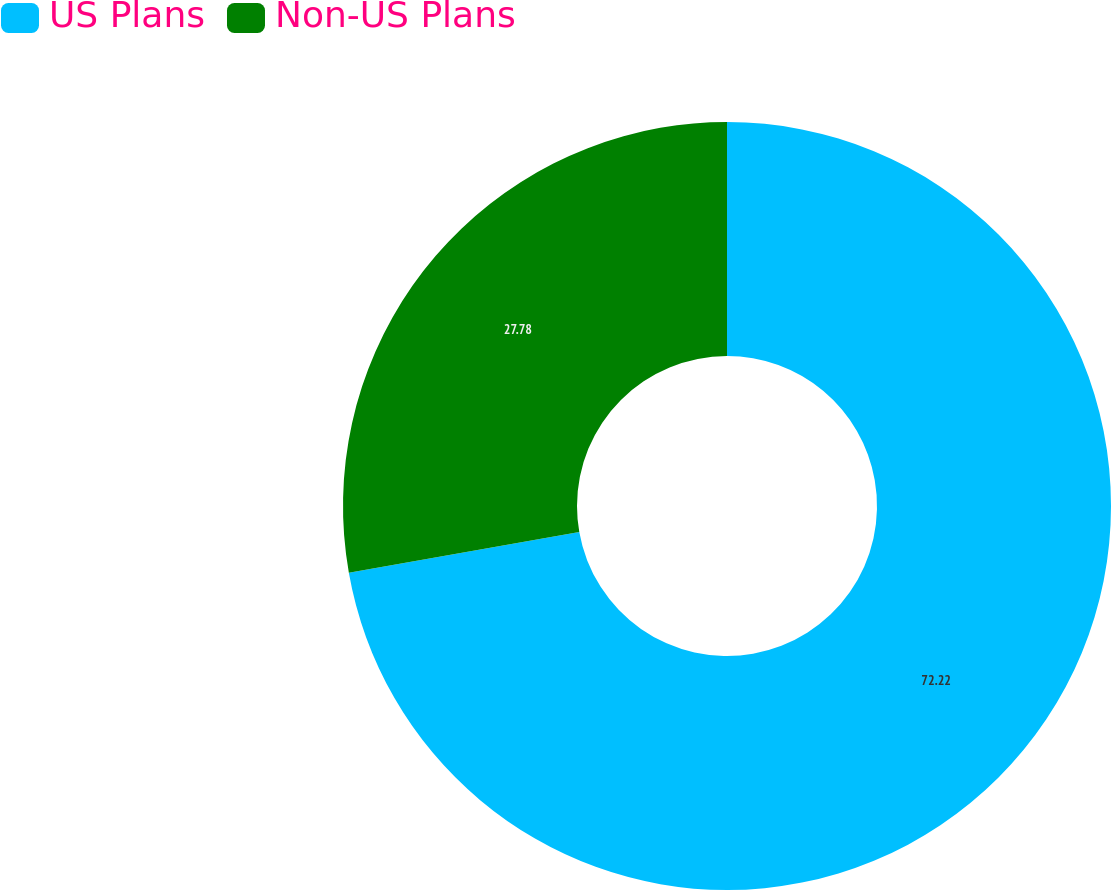<chart> <loc_0><loc_0><loc_500><loc_500><pie_chart><fcel>US Plans<fcel>Non-US Plans<nl><fcel>72.22%<fcel>27.78%<nl></chart> 